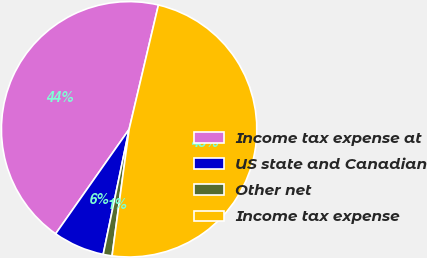<chart> <loc_0><loc_0><loc_500><loc_500><pie_chart><fcel>Income tax expense at<fcel>US state and Canadian<fcel>Other net<fcel>Income tax expense<nl><fcel>43.93%<fcel>6.5%<fcel>1.12%<fcel>48.45%<nl></chart> 